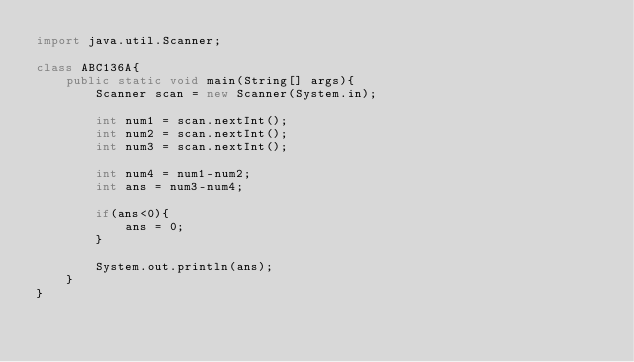<code> <loc_0><loc_0><loc_500><loc_500><_Java_>import java.util.Scanner;

class ABC136A{
	public static void main(String[] args){
		Scanner scan = new Scanner(System.in);
		
		int num1 = scan.nextInt();
		int num2 = scan.nextInt();
		int num3 = scan.nextInt();
		
		int num4 = num1-num2;
		int ans = num3-num4;
		
		if(ans<0){
			ans = 0;
		}
		
		System.out.println(ans);
	}
}</code> 